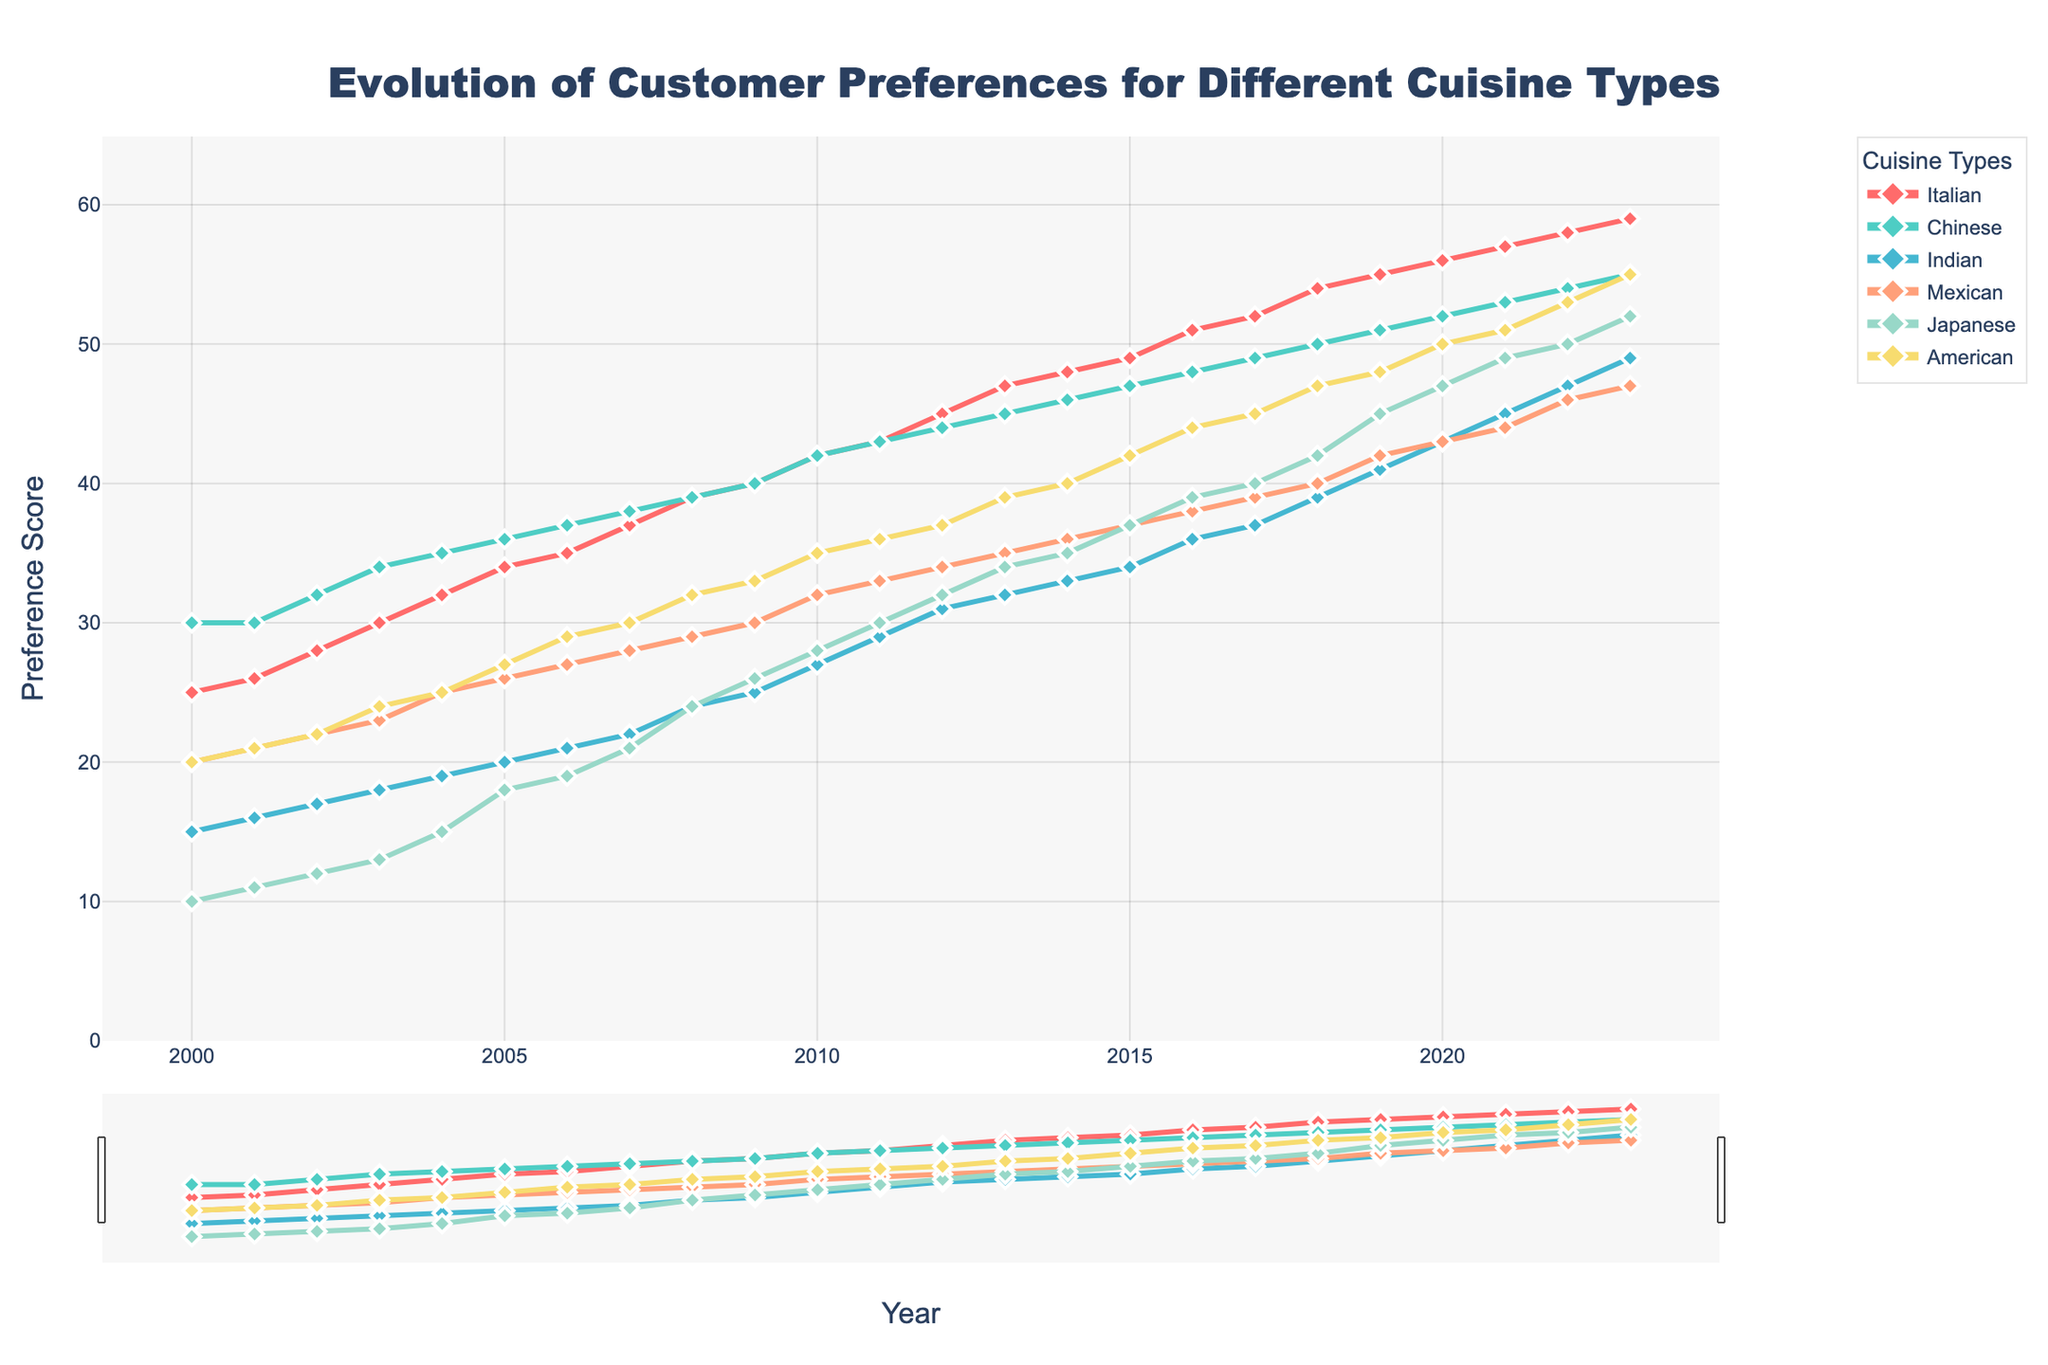what is the average preference score for Italian cuisine over the years? To find the average, sum all preference scores for Italian cuisine from 2000 to 2023, then divide by the number of years. (25+26+28+30+32+34+35+37+39+40+42+43+45+47+48+49+51+52+54+55+56+57+58+59) / 24 = 41.5
Answer: 41.5 Which cuisine type shows the greatest increase in preference from 2000 to 2023? Calculate the difference for each cuisine type between scores in 2000 and 2023. Italian: 59-25=34, Chinese: 55-30=25, Indian: 49-15=34, Mexican: 47-20=27, Japanese: 52-10=42, American: 55-20=35. Japanese shows the greatest increase.
Answer: Japanese What is the lowest preference score across all cuisine types in 2010? Look at the preference scores for all cuisine types in 2010. Italian: 42, Chinese: 42, Indian: 27, Mexican: 32, Japanese: 28, American: 35. The lowest score is 27 for Indian cuisine.
Answer: Indian Between which years did Mexican cuisine preference see the highest growth? Check the year-on-year changes for Mexican cuisine and find the highest increase. Biggest jumps are from 2004-2005 (25-26) and 2018-2019 (40-42), but 2000-2001 (20-21 = 1) shows other years have equal or lower increases.
Answer: 2018-2019 What is the combined preference score for American cuisine from 2016 to 2020? Sum American cuisine scores from 2016 (44) to 2020 (50). 44 + 45 + 47 + 48 + 50 = 234
Answer: 234 Which cuisine surpassed the preference score of 40 first, and when? Check when each cuisine type first reached a score greater than 40. Chinese reached 40 in 2009, so it's the first cuisine to surpass 40.
Answer: Chinese, 2009 How many cuisine types had a preference score above 50 in 2023? Look at the 2023 preference scores for all cuisine types and count those above 50. Italian: 59, Chinese: 55, Indian: 49, Mexican: 47, Japanese: 52, American: 55. Four types are above 50.
Answer: 4 What is the general trend for Indian cuisine preference scores from 2000 to 2023? Observe how Indian cuisine scores change from 2000 (15) to 2023 (49). There is a steady increase over the years.
Answer: Increasing Which two cuisines showed the most similar patterns of preference growth from 2000 to 2023? Compare the patterns of preference growth for all cuisines from 2000 to 2023. Italian and Indian both see substantial growth and incremental increases in similar patterns.
Answer: Italian and Indian In which year did Japanese cuisine cross the 30 preference score mark? Find the year that Japanese first scored over 30. It surpassed 30 in 2011 and continued to increase.
Answer: 2011 